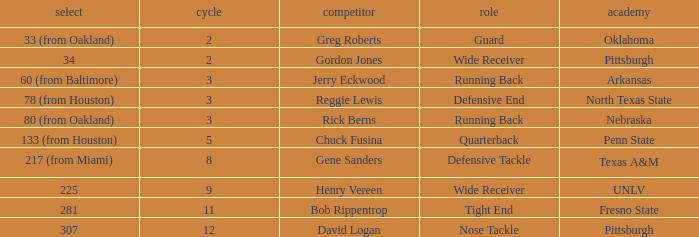What round was the nose tackle drafted? 12.0. 